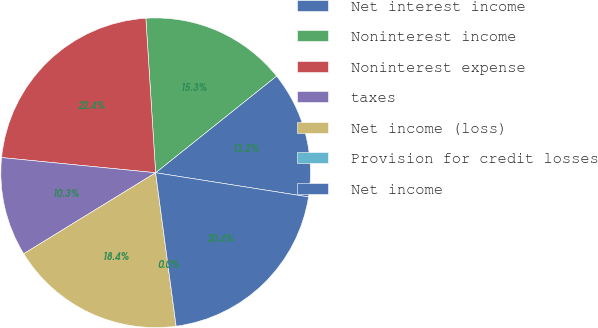Convert chart to OTSL. <chart><loc_0><loc_0><loc_500><loc_500><pie_chart><fcel>Net interest income<fcel>Noninterest income<fcel>Noninterest expense<fcel>taxes<fcel>Net income (loss)<fcel>Provision for credit losses<fcel>Net income<nl><fcel>13.23%<fcel>15.27%<fcel>22.43%<fcel>10.33%<fcel>18.35%<fcel>0.0%<fcel>20.39%<nl></chart> 